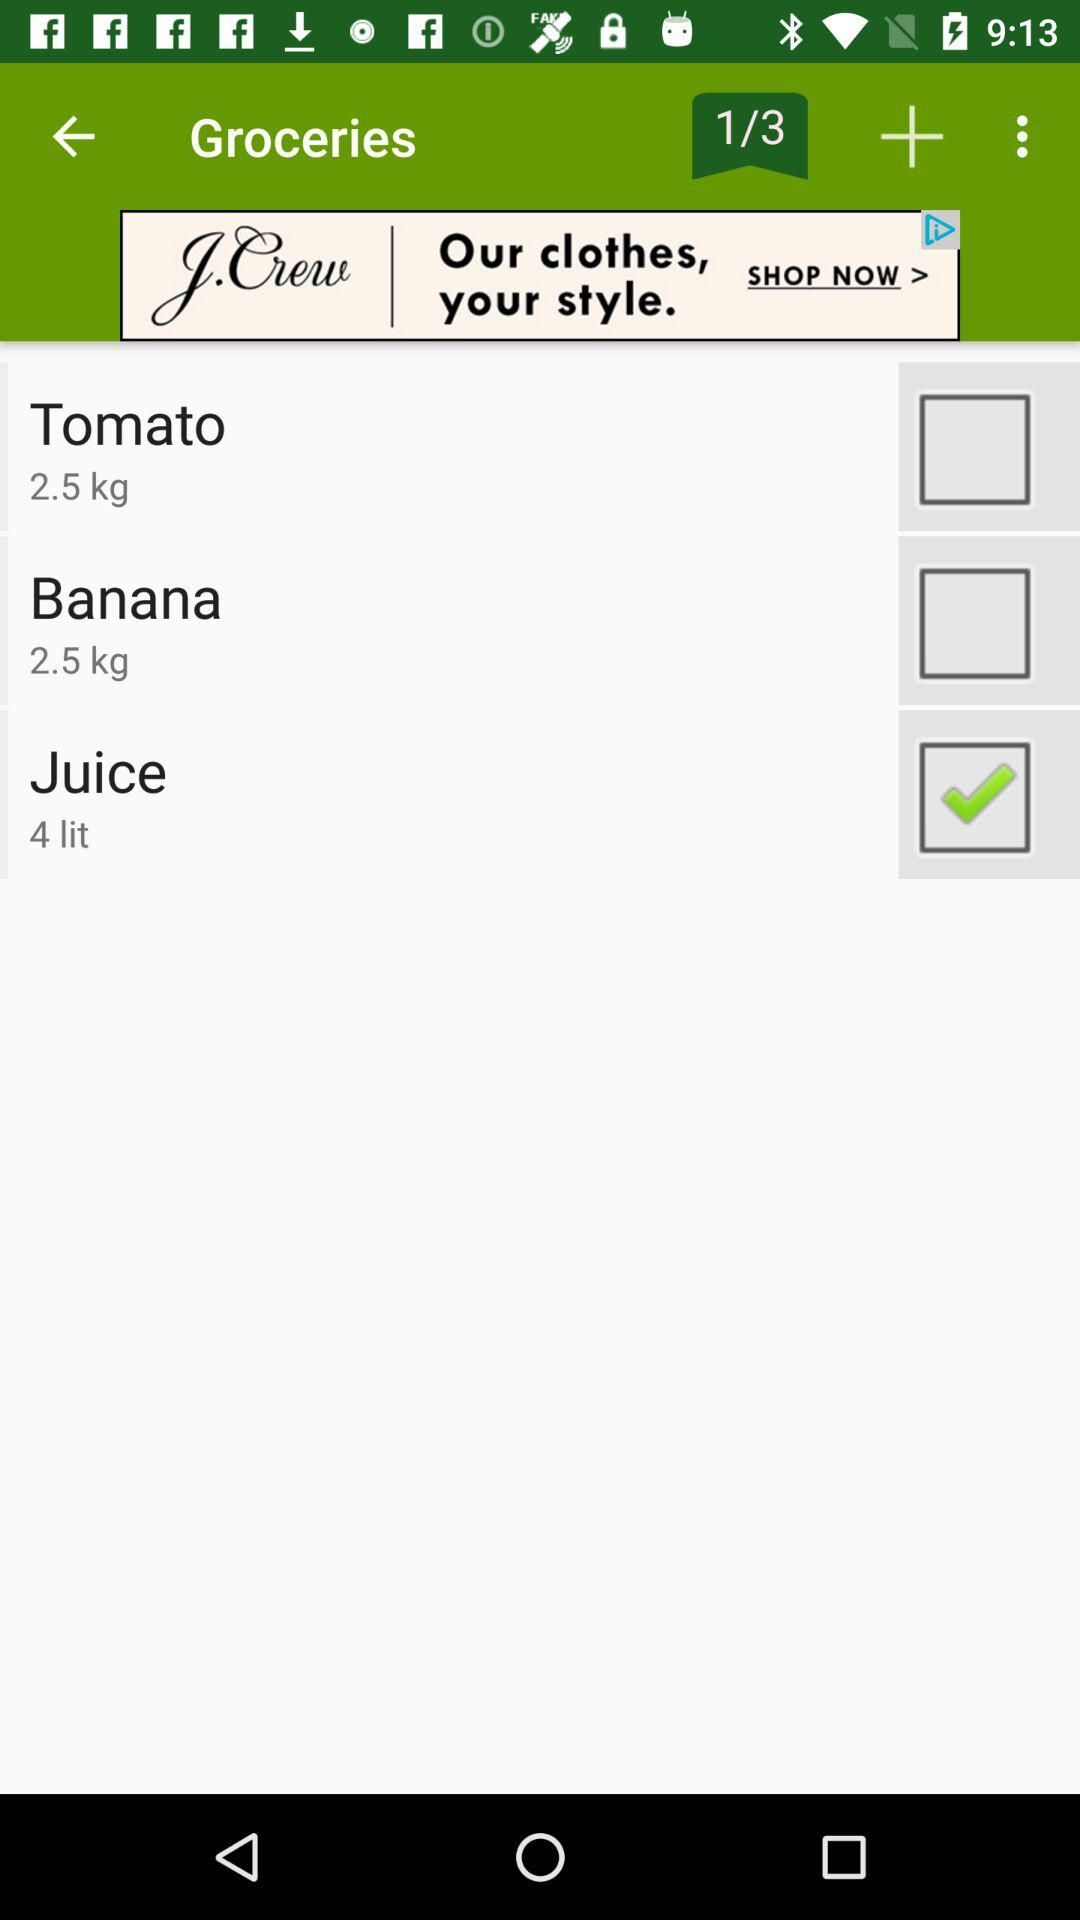What is the weight of tomatoes? The weight of tomatoes is 2.5 kg. 